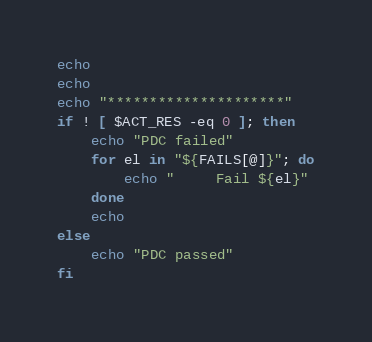<code> <loc_0><loc_0><loc_500><loc_500><_Bash_>echo 
echo
echo "*********************"
if ! [ $ACT_RES -eq 0 ]; then
	echo "PDC failed"
	for el in "${FAILS[@]}"; do
		echo "     Fail ${el}"
	done
	echo
else
	echo "PDC passed"
fi
</code> 